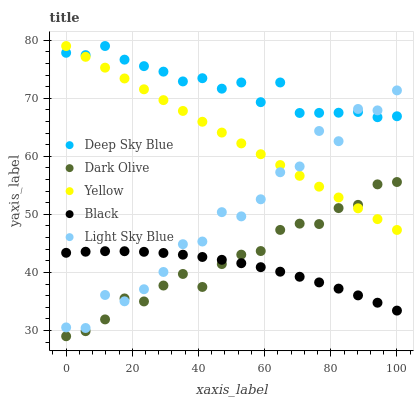Does Black have the minimum area under the curve?
Answer yes or no. Yes. Does Deep Sky Blue have the maximum area under the curve?
Answer yes or no. Yes. Does Yellow have the minimum area under the curve?
Answer yes or no. No. Does Yellow have the maximum area under the curve?
Answer yes or no. No. Is Yellow the smoothest?
Answer yes or no. Yes. Is Light Sky Blue the roughest?
Answer yes or no. Yes. Is Black the smoothest?
Answer yes or no. No. Is Black the roughest?
Answer yes or no. No. Does Dark Olive have the lowest value?
Answer yes or no. Yes. Does Black have the lowest value?
Answer yes or no. No. Does Deep Sky Blue have the highest value?
Answer yes or no. Yes. Does Black have the highest value?
Answer yes or no. No. Is Black less than Deep Sky Blue?
Answer yes or no. Yes. Is Deep Sky Blue greater than Dark Olive?
Answer yes or no. Yes. Does Dark Olive intersect Yellow?
Answer yes or no. Yes. Is Dark Olive less than Yellow?
Answer yes or no. No. Is Dark Olive greater than Yellow?
Answer yes or no. No. Does Black intersect Deep Sky Blue?
Answer yes or no. No. 